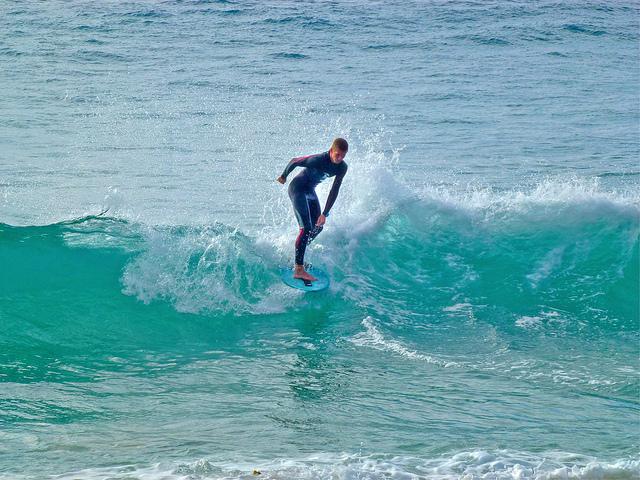How does a surfboard stay on top of the water?
Write a very short answer. Floats. What wave is the surfer riding on?
Write a very short answer. Small. What color hat is the man wearing?
Give a very brief answer. None. What color is the water?
Keep it brief. Blue. Is this person a novice?
Concise answer only. No. Is the surfer wearing a wetsuit?
Give a very brief answer. Yes. Is the surfer going down?
Quick response, please. No. What color are the surfer's shorts?
Give a very brief answer. Blue. Does this man have long hair?
Answer briefly. No. How does the wetsuit help the surfer?
Short answer required. Warmth. 